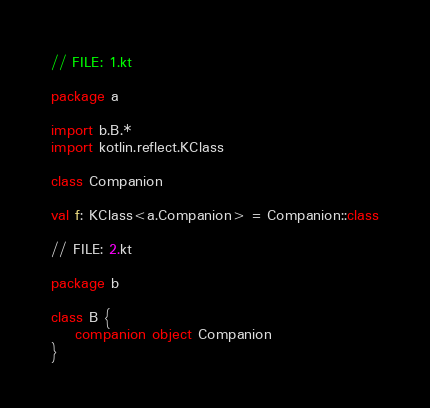Convert code to text. <code><loc_0><loc_0><loc_500><loc_500><_Kotlin_>// FILE: 1.kt

package a

import b.B.*
import kotlin.reflect.KClass

class Companion

val f: KClass<a.Companion> = Companion::class

// FILE: 2.kt

package b

class B {
    companion object Companion
}
</code> 